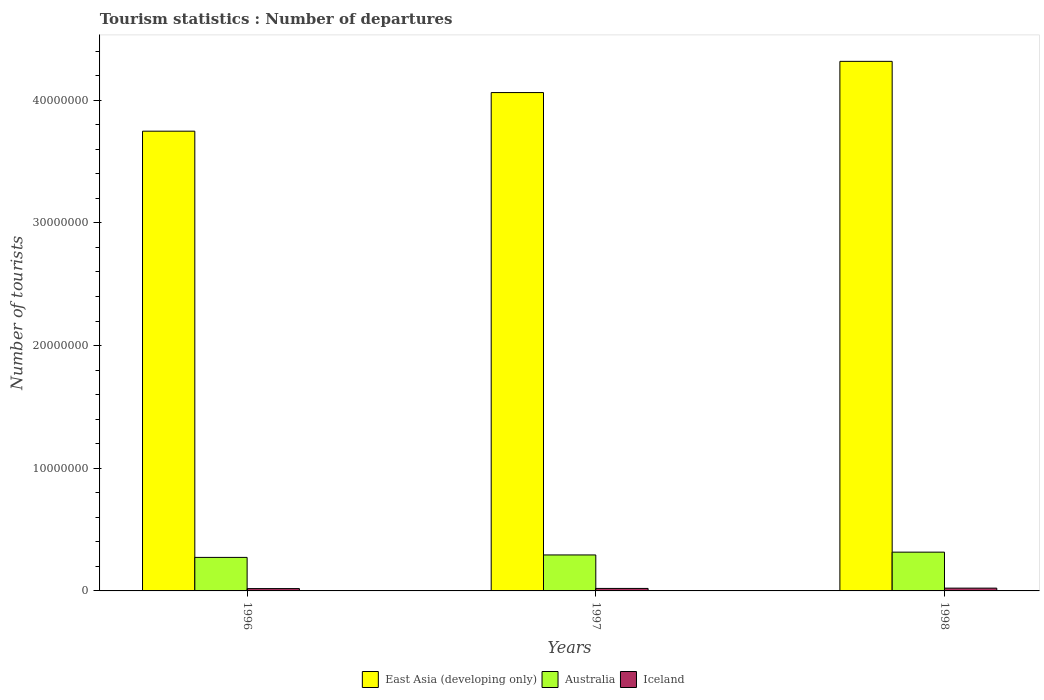How many groups of bars are there?
Make the answer very short. 3. Are the number of bars on each tick of the X-axis equal?
Give a very brief answer. Yes. What is the label of the 1st group of bars from the left?
Keep it short and to the point. 1996. What is the number of tourist departures in East Asia (developing only) in 1997?
Provide a succinct answer. 4.06e+07. Across all years, what is the maximum number of tourist departures in East Asia (developing only)?
Give a very brief answer. 4.32e+07. Across all years, what is the minimum number of tourist departures in Iceland?
Make the answer very short. 1.90e+05. In which year was the number of tourist departures in East Asia (developing only) minimum?
Your response must be concise. 1996. What is the total number of tourist departures in Australia in the graph?
Make the answer very short. 8.83e+06. What is the difference between the number of tourist departures in Australia in 1996 and that in 1998?
Offer a terse response. -4.29e+05. What is the difference between the number of tourist departures in Iceland in 1998 and the number of tourist departures in Australia in 1996?
Ensure brevity in your answer.  -2.50e+06. What is the average number of tourist departures in Iceland per year?
Provide a succinct answer. 2.07e+05. In the year 1998, what is the difference between the number of tourist departures in East Asia (developing only) and number of tourist departures in Australia?
Keep it short and to the point. 4.00e+07. In how many years, is the number of tourist departures in East Asia (developing only) greater than 12000000?
Your answer should be compact. 3. What is the ratio of the number of tourist departures in East Asia (developing only) in 1996 to that in 1998?
Make the answer very short. 0.87. Is the difference between the number of tourist departures in East Asia (developing only) in 1997 and 1998 greater than the difference between the number of tourist departures in Australia in 1997 and 1998?
Offer a very short reply. No. What is the difference between the highest and the second highest number of tourist departures in East Asia (developing only)?
Keep it short and to the point. 2.54e+06. What is the difference between the highest and the lowest number of tourist departures in East Asia (developing only)?
Provide a succinct answer. 5.69e+06. In how many years, is the number of tourist departures in East Asia (developing only) greater than the average number of tourist departures in East Asia (developing only) taken over all years?
Your response must be concise. 2. What does the 2nd bar from the left in 1998 represents?
Your response must be concise. Australia. What does the 3rd bar from the right in 1998 represents?
Keep it short and to the point. East Asia (developing only). How many bars are there?
Make the answer very short. 9. Are all the bars in the graph horizontal?
Make the answer very short. No. Are the values on the major ticks of Y-axis written in scientific E-notation?
Ensure brevity in your answer.  No. Does the graph contain any zero values?
Your answer should be very brief. No. Does the graph contain grids?
Ensure brevity in your answer.  No. Where does the legend appear in the graph?
Provide a succinct answer. Bottom center. What is the title of the graph?
Provide a succinct answer. Tourism statistics : Number of departures. Does "Guatemala" appear as one of the legend labels in the graph?
Ensure brevity in your answer.  No. What is the label or title of the X-axis?
Ensure brevity in your answer.  Years. What is the label or title of the Y-axis?
Ensure brevity in your answer.  Number of tourists. What is the Number of tourists in East Asia (developing only) in 1996?
Ensure brevity in your answer.  3.75e+07. What is the Number of tourists of Australia in 1996?
Your answer should be compact. 2.73e+06. What is the Number of tourists of Iceland in 1996?
Your answer should be compact. 1.90e+05. What is the Number of tourists of East Asia (developing only) in 1997?
Give a very brief answer. 4.06e+07. What is the Number of tourists of Australia in 1997?
Offer a terse response. 2.93e+06. What is the Number of tourists of Iceland in 1997?
Make the answer very short. 2.03e+05. What is the Number of tourists of East Asia (developing only) in 1998?
Your answer should be compact. 4.32e+07. What is the Number of tourists in Australia in 1998?
Offer a terse response. 3.16e+06. What is the Number of tourists of Iceland in 1998?
Give a very brief answer. 2.27e+05. Across all years, what is the maximum Number of tourists in East Asia (developing only)?
Provide a short and direct response. 4.32e+07. Across all years, what is the maximum Number of tourists of Australia?
Provide a succinct answer. 3.16e+06. Across all years, what is the maximum Number of tourists of Iceland?
Your answer should be compact. 2.27e+05. Across all years, what is the minimum Number of tourists in East Asia (developing only)?
Your response must be concise. 3.75e+07. Across all years, what is the minimum Number of tourists in Australia?
Offer a terse response. 2.73e+06. Across all years, what is the minimum Number of tourists in Iceland?
Offer a very short reply. 1.90e+05. What is the total Number of tourists in East Asia (developing only) in the graph?
Give a very brief answer. 1.21e+08. What is the total Number of tourists of Australia in the graph?
Offer a very short reply. 8.83e+06. What is the total Number of tourists of Iceland in the graph?
Your answer should be compact. 6.20e+05. What is the difference between the Number of tourists of East Asia (developing only) in 1996 and that in 1997?
Provide a succinct answer. -3.15e+06. What is the difference between the Number of tourists in Australia in 1996 and that in 1997?
Your response must be concise. -2.01e+05. What is the difference between the Number of tourists in Iceland in 1996 and that in 1997?
Ensure brevity in your answer.  -1.30e+04. What is the difference between the Number of tourists of East Asia (developing only) in 1996 and that in 1998?
Offer a terse response. -5.69e+06. What is the difference between the Number of tourists of Australia in 1996 and that in 1998?
Offer a terse response. -4.29e+05. What is the difference between the Number of tourists of Iceland in 1996 and that in 1998?
Offer a very short reply. -3.70e+04. What is the difference between the Number of tourists in East Asia (developing only) in 1997 and that in 1998?
Your answer should be compact. -2.54e+06. What is the difference between the Number of tourists of Australia in 1997 and that in 1998?
Your answer should be very brief. -2.28e+05. What is the difference between the Number of tourists in Iceland in 1997 and that in 1998?
Make the answer very short. -2.40e+04. What is the difference between the Number of tourists in East Asia (developing only) in 1996 and the Number of tourists in Australia in 1997?
Provide a short and direct response. 3.45e+07. What is the difference between the Number of tourists of East Asia (developing only) in 1996 and the Number of tourists of Iceland in 1997?
Make the answer very short. 3.73e+07. What is the difference between the Number of tourists in Australia in 1996 and the Number of tourists in Iceland in 1997?
Your response must be concise. 2.53e+06. What is the difference between the Number of tourists of East Asia (developing only) in 1996 and the Number of tourists of Australia in 1998?
Give a very brief answer. 3.43e+07. What is the difference between the Number of tourists of East Asia (developing only) in 1996 and the Number of tourists of Iceland in 1998?
Your answer should be compact. 3.72e+07. What is the difference between the Number of tourists of Australia in 1996 and the Number of tourists of Iceland in 1998?
Provide a succinct answer. 2.50e+06. What is the difference between the Number of tourists in East Asia (developing only) in 1997 and the Number of tourists in Australia in 1998?
Your answer should be compact. 3.75e+07. What is the difference between the Number of tourists in East Asia (developing only) in 1997 and the Number of tourists in Iceland in 1998?
Provide a succinct answer. 4.04e+07. What is the difference between the Number of tourists in Australia in 1997 and the Number of tourists in Iceland in 1998?
Offer a terse response. 2.71e+06. What is the average Number of tourists in East Asia (developing only) per year?
Ensure brevity in your answer.  4.04e+07. What is the average Number of tourists of Australia per year?
Offer a terse response. 2.94e+06. What is the average Number of tourists of Iceland per year?
Give a very brief answer. 2.07e+05. In the year 1996, what is the difference between the Number of tourists in East Asia (developing only) and Number of tourists in Australia?
Keep it short and to the point. 3.47e+07. In the year 1996, what is the difference between the Number of tourists in East Asia (developing only) and Number of tourists in Iceland?
Keep it short and to the point. 3.73e+07. In the year 1996, what is the difference between the Number of tourists of Australia and Number of tourists of Iceland?
Give a very brief answer. 2.54e+06. In the year 1997, what is the difference between the Number of tourists of East Asia (developing only) and Number of tourists of Australia?
Your answer should be very brief. 3.77e+07. In the year 1997, what is the difference between the Number of tourists in East Asia (developing only) and Number of tourists in Iceland?
Provide a short and direct response. 4.04e+07. In the year 1997, what is the difference between the Number of tourists in Australia and Number of tourists in Iceland?
Your answer should be very brief. 2.73e+06. In the year 1998, what is the difference between the Number of tourists in East Asia (developing only) and Number of tourists in Australia?
Your answer should be compact. 4.00e+07. In the year 1998, what is the difference between the Number of tourists in East Asia (developing only) and Number of tourists in Iceland?
Make the answer very short. 4.29e+07. In the year 1998, what is the difference between the Number of tourists in Australia and Number of tourists in Iceland?
Your answer should be compact. 2.93e+06. What is the ratio of the Number of tourists of East Asia (developing only) in 1996 to that in 1997?
Your response must be concise. 0.92. What is the ratio of the Number of tourists of Australia in 1996 to that in 1997?
Keep it short and to the point. 0.93. What is the ratio of the Number of tourists in Iceland in 1996 to that in 1997?
Offer a very short reply. 0.94. What is the ratio of the Number of tourists of East Asia (developing only) in 1996 to that in 1998?
Keep it short and to the point. 0.87. What is the ratio of the Number of tourists in Australia in 1996 to that in 1998?
Your answer should be very brief. 0.86. What is the ratio of the Number of tourists of Iceland in 1996 to that in 1998?
Your response must be concise. 0.84. What is the ratio of the Number of tourists of East Asia (developing only) in 1997 to that in 1998?
Your answer should be compact. 0.94. What is the ratio of the Number of tourists of Australia in 1997 to that in 1998?
Give a very brief answer. 0.93. What is the ratio of the Number of tourists of Iceland in 1997 to that in 1998?
Make the answer very short. 0.89. What is the difference between the highest and the second highest Number of tourists in East Asia (developing only)?
Your answer should be compact. 2.54e+06. What is the difference between the highest and the second highest Number of tourists of Australia?
Offer a terse response. 2.28e+05. What is the difference between the highest and the second highest Number of tourists of Iceland?
Make the answer very short. 2.40e+04. What is the difference between the highest and the lowest Number of tourists in East Asia (developing only)?
Offer a terse response. 5.69e+06. What is the difference between the highest and the lowest Number of tourists of Australia?
Offer a terse response. 4.29e+05. What is the difference between the highest and the lowest Number of tourists of Iceland?
Your answer should be very brief. 3.70e+04. 